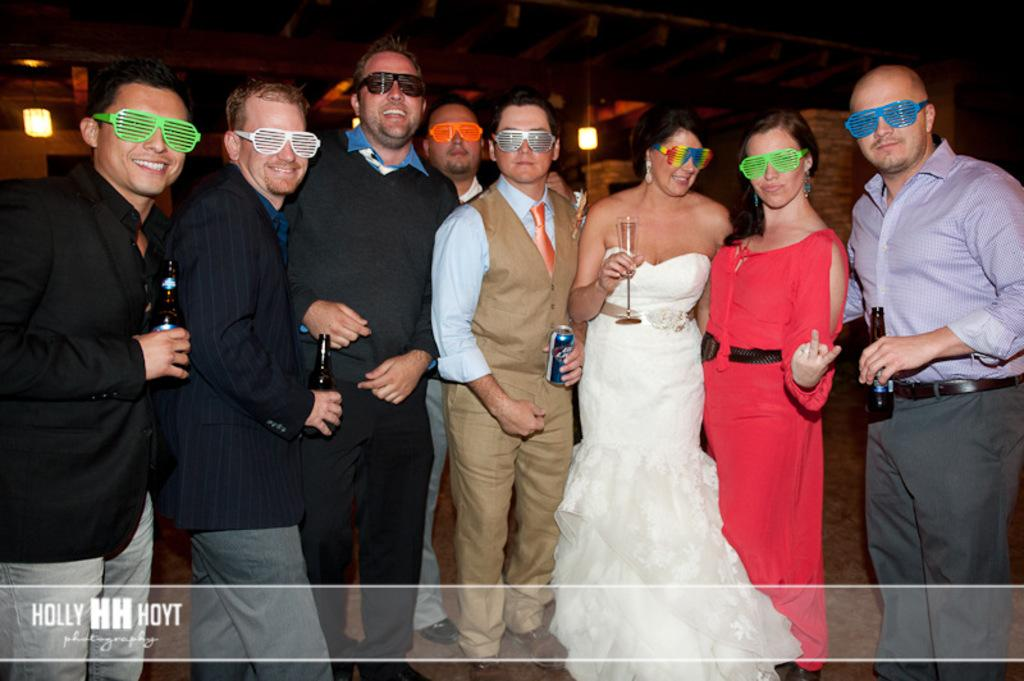What can be seen in the image? There is a group of people in the image. What are the people wearing? The people are wearing spectacles. What can be seen in the background of the image? There are lights visible in the background of the image. What type of chalk is being used by the people in the image? There is no chalk present in the image; the people are wearing spectacles. What sense is being stimulated by the lights in the image? The provided facts do not mention any specific sense being stimulated by the lights in the image. 